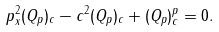Convert formula to latex. <formula><loc_0><loc_0><loc_500><loc_500>\ p _ { x } ^ { 2 } ( Q _ { p } ) _ { c } - c ^ { 2 } ( Q _ { p } ) _ { c } + ( Q _ { p } ) _ { c } ^ { p } = 0 .</formula> 